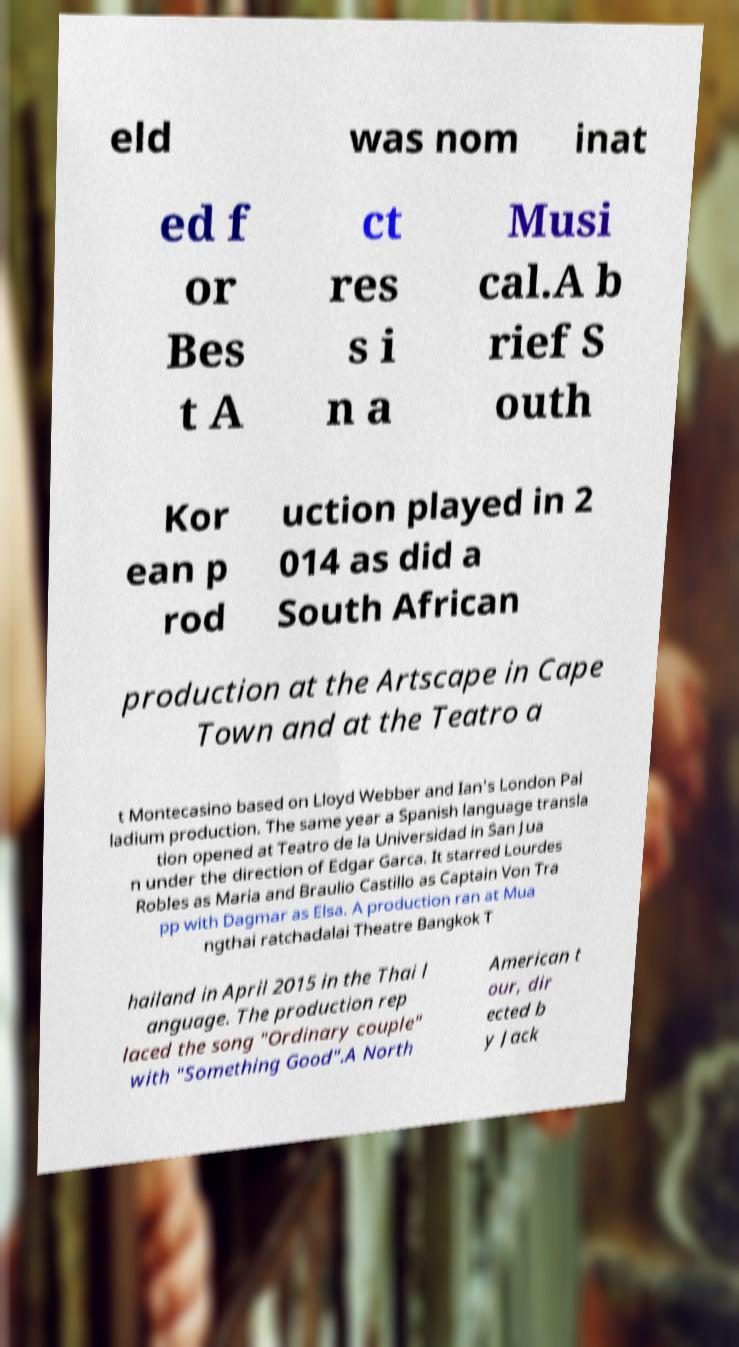Could you extract and type out the text from this image? eld was nom inat ed f or Bes t A ct res s i n a Musi cal.A b rief S outh Kor ean p rod uction played in 2 014 as did a South African production at the Artscape in Cape Town and at the Teatro a t Montecasino based on Lloyd Webber and Ian's London Pal ladium production. The same year a Spanish language transla tion opened at Teatro de la Universidad in San Jua n under the direction of Edgar Garca. It starred Lourdes Robles as Maria and Braulio Castillo as Captain Von Tra pp with Dagmar as Elsa. A production ran at Mua ngthai ratchadalai Theatre Bangkok T hailand in April 2015 in the Thai l anguage. The production rep laced the song "Ordinary couple" with "Something Good".A North American t our, dir ected b y Jack 